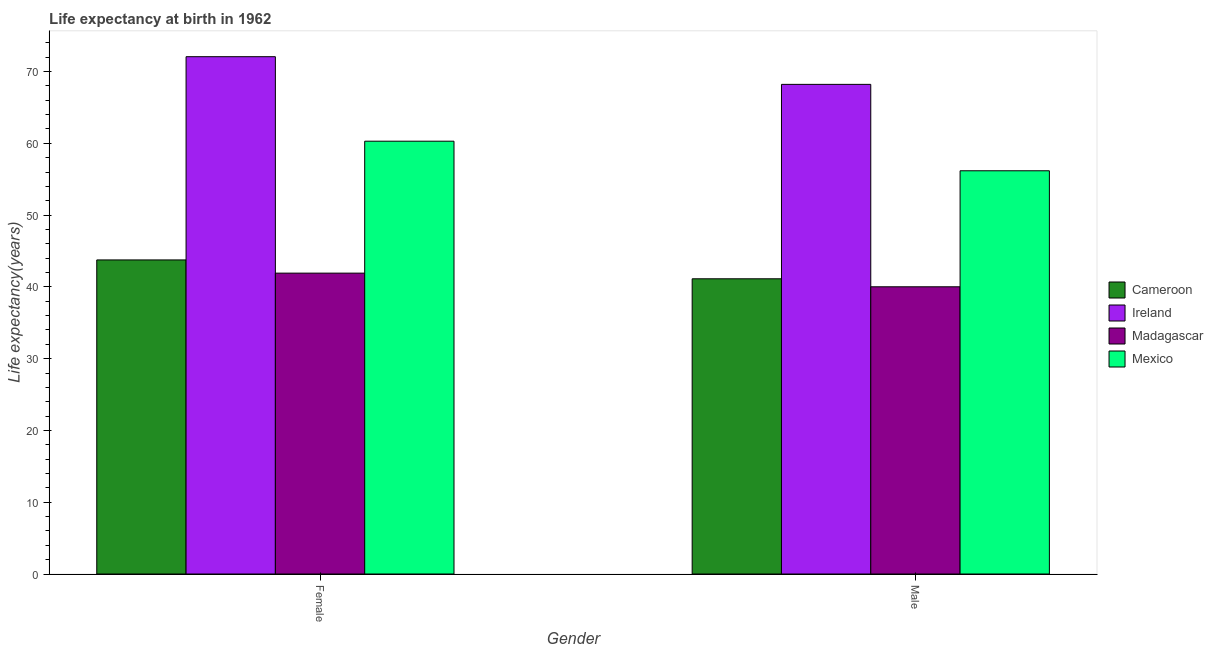How many different coloured bars are there?
Offer a very short reply. 4. How many bars are there on the 2nd tick from the right?
Your answer should be compact. 4. What is the life expectancy(male) in Madagascar?
Offer a terse response. 40.01. Across all countries, what is the maximum life expectancy(male)?
Ensure brevity in your answer.  68.21. Across all countries, what is the minimum life expectancy(male)?
Your response must be concise. 40.01. In which country was the life expectancy(female) maximum?
Give a very brief answer. Ireland. In which country was the life expectancy(male) minimum?
Offer a very short reply. Madagascar. What is the total life expectancy(male) in the graph?
Offer a very short reply. 205.51. What is the difference between the life expectancy(male) in Ireland and that in Mexico?
Give a very brief answer. 12.04. What is the difference between the life expectancy(female) in Madagascar and the life expectancy(male) in Mexico?
Your answer should be very brief. -14.26. What is the average life expectancy(female) per country?
Give a very brief answer. 54.5. What is the difference between the life expectancy(male) and life expectancy(female) in Mexico?
Give a very brief answer. -4.12. What is the ratio of the life expectancy(female) in Cameroon to that in Mexico?
Give a very brief answer. 0.73. Is the life expectancy(male) in Madagascar less than that in Mexico?
Your response must be concise. Yes. What does the 3rd bar from the left in Male represents?
Keep it short and to the point. Madagascar. What does the 4th bar from the right in Female represents?
Offer a very short reply. Cameroon. How many bars are there?
Provide a short and direct response. 8. Are all the bars in the graph horizontal?
Your response must be concise. No. What is the difference between two consecutive major ticks on the Y-axis?
Your response must be concise. 10. Are the values on the major ticks of Y-axis written in scientific E-notation?
Ensure brevity in your answer.  No. Does the graph contain any zero values?
Your answer should be compact. No. Does the graph contain grids?
Give a very brief answer. No. Where does the legend appear in the graph?
Make the answer very short. Center right. How many legend labels are there?
Provide a succinct answer. 4. How are the legend labels stacked?
Provide a short and direct response. Vertical. What is the title of the graph?
Offer a very short reply. Life expectancy at birth in 1962. Does "Turks and Caicos Islands" appear as one of the legend labels in the graph?
Keep it short and to the point. No. What is the label or title of the Y-axis?
Give a very brief answer. Life expectancy(years). What is the Life expectancy(years) in Cameroon in Female?
Offer a terse response. 43.75. What is the Life expectancy(years) in Ireland in Female?
Offer a terse response. 72.06. What is the Life expectancy(years) in Madagascar in Female?
Your answer should be compact. 41.91. What is the Life expectancy(years) of Mexico in Female?
Make the answer very short. 60.29. What is the Life expectancy(years) in Cameroon in Male?
Ensure brevity in your answer.  41.12. What is the Life expectancy(years) of Ireland in Male?
Your response must be concise. 68.21. What is the Life expectancy(years) of Madagascar in Male?
Your answer should be very brief. 40.01. What is the Life expectancy(years) of Mexico in Male?
Offer a very short reply. 56.17. Across all Gender, what is the maximum Life expectancy(years) of Cameroon?
Your answer should be compact. 43.75. Across all Gender, what is the maximum Life expectancy(years) in Ireland?
Provide a short and direct response. 72.06. Across all Gender, what is the maximum Life expectancy(years) of Madagascar?
Keep it short and to the point. 41.91. Across all Gender, what is the maximum Life expectancy(years) of Mexico?
Your answer should be very brief. 60.29. Across all Gender, what is the minimum Life expectancy(years) of Cameroon?
Ensure brevity in your answer.  41.12. Across all Gender, what is the minimum Life expectancy(years) of Ireland?
Offer a very short reply. 68.21. Across all Gender, what is the minimum Life expectancy(years) in Madagascar?
Provide a short and direct response. 40.01. Across all Gender, what is the minimum Life expectancy(years) in Mexico?
Your response must be concise. 56.17. What is the total Life expectancy(years) in Cameroon in the graph?
Your response must be concise. 84.88. What is the total Life expectancy(years) of Ireland in the graph?
Your response must be concise. 140.27. What is the total Life expectancy(years) of Madagascar in the graph?
Offer a very short reply. 81.92. What is the total Life expectancy(years) in Mexico in the graph?
Give a very brief answer. 116.46. What is the difference between the Life expectancy(years) of Cameroon in Female and that in Male?
Your response must be concise. 2.63. What is the difference between the Life expectancy(years) in Ireland in Female and that in Male?
Provide a short and direct response. 3.86. What is the difference between the Life expectancy(years) in Madagascar in Female and that in Male?
Your response must be concise. 1.9. What is the difference between the Life expectancy(years) of Mexico in Female and that in Male?
Give a very brief answer. 4.12. What is the difference between the Life expectancy(years) of Cameroon in Female and the Life expectancy(years) of Ireland in Male?
Your answer should be compact. -24.45. What is the difference between the Life expectancy(years) of Cameroon in Female and the Life expectancy(years) of Madagascar in Male?
Give a very brief answer. 3.74. What is the difference between the Life expectancy(years) of Cameroon in Female and the Life expectancy(years) of Mexico in Male?
Keep it short and to the point. -12.42. What is the difference between the Life expectancy(years) in Ireland in Female and the Life expectancy(years) in Madagascar in Male?
Provide a short and direct response. 32.05. What is the difference between the Life expectancy(years) of Ireland in Female and the Life expectancy(years) of Mexico in Male?
Provide a short and direct response. 15.89. What is the difference between the Life expectancy(years) in Madagascar in Female and the Life expectancy(years) in Mexico in Male?
Your answer should be compact. -14.26. What is the average Life expectancy(years) in Cameroon per Gender?
Offer a terse response. 42.44. What is the average Life expectancy(years) in Ireland per Gender?
Provide a succinct answer. 70.14. What is the average Life expectancy(years) of Madagascar per Gender?
Provide a short and direct response. 40.96. What is the average Life expectancy(years) in Mexico per Gender?
Offer a very short reply. 58.23. What is the difference between the Life expectancy(years) in Cameroon and Life expectancy(years) in Ireland in Female?
Your answer should be very brief. -28.31. What is the difference between the Life expectancy(years) in Cameroon and Life expectancy(years) in Madagascar in Female?
Your answer should be compact. 1.84. What is the difference between the Life expectancy(years) of Cameroon and Life expectancy(years) of Mexico in Female?
Keep it short and to the point. -16.54. What is the difference between the Life expectancy(years) of Ireland and Life expectancy(years) of Madagascar in Female?
Offer a very short reply. 30.15. What is the difference between the Life expectancy(years) of Ireland and Life expectancy(years) of Mexico in Female?
Provide a succinct answer. 11.77. What is the difference between the Life expectancy(years) of Madagascar and Life expectancy(years) of Mexico in Female?
Your response must be concise. -18.38. What is the difference between the Life expectancy(years) of Cameroon and Life expectancy(years) of Ireland in Male?
Keep it short and to the point. -27.08. What is the difference between the Life expectancy(years) of Cameroon and Life expectancy(years) of Madagascar in Male?
Give a very brief answer. 1.11. What is the difference between the Life expectancy(years) in Cameroon and Life expectancy(years) in Mexico in Male?
Your response must be concise. -15.05. What is the difference between the Life expectancy(years) in Ireland and Life expectancy(years) in Madagascar in Male?
Ensure brevity in your answer.  28.2. What is the difference between the Life expectancy(years) of Ireland and Life expectancy(years) of Mexico in Male?
Give a very brief answer. 12.04. What is the difference between the Life expectancy(years) in Madagascar and Life expectancy(years) in Mexico in Male?
Offer a terse response. -16.16. What is the ratio of the Life expectancy(years) in Cameroon in Female to that in Male?
Offer a terse response. 1.06. What is the ratio of the Life expectancy(years) in Ireland in Female to that in Male?
Provide a succinct answer. 1.06. What is the ratio of the Life expectancy(years) of Madagascar in Female to that in Male?
Give a very brief answer. 1.05. What is the ratio of the Life expectancy(years) in Mexico in Female to that in Male?
Make the answer very short. 1.07. What is the difference between the highest and the second highest Life expectancy(years) in Cameroon?
Offer a terse response. 2.63. What is the difference between the highest and the second highest Life expectancy(years) of Ireland?
Provide a short and direct response. 3.86. What is the difference between the highest and the second highest Life expectancy(years) of Madagascar?
Your answer should be very brief. 1.9. What is the difference between the highest and the second highest Life expectancy(years) of Mexico?
Give a very brief answer. 4.12. What is the difference between the highest and the lowest Life expectancy(years) in Cameroon?
Your response must be concise. 2.63. What is the difference between the highest and the lowest Life expectancy(years) of Ireland?
Ensure brevity in your answer.  3.86. What is the difference between the highest and the lowest Life expectancy(years) of Madagascar?
Keep it short and to the point. 1.9. What is the difference between the highest and the lowest Life expectancy(years) in Mexico?
Your answer should be very brief. 4.12. 